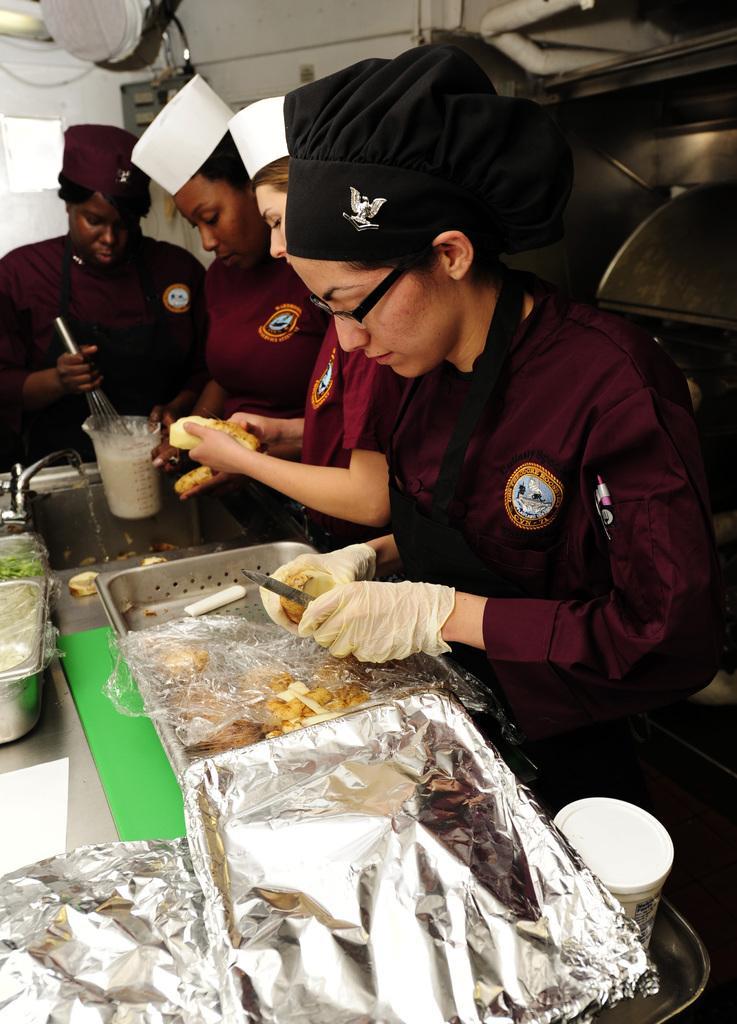Describe this image in one or two sentences. In this image I can see the group of people with maroon color dresses and also aprons. In-front of these people I can see many utensils, jug with liquid, tap, sink and one person holding the knife and an another person holding the jug. In the background I can see the white wall. 